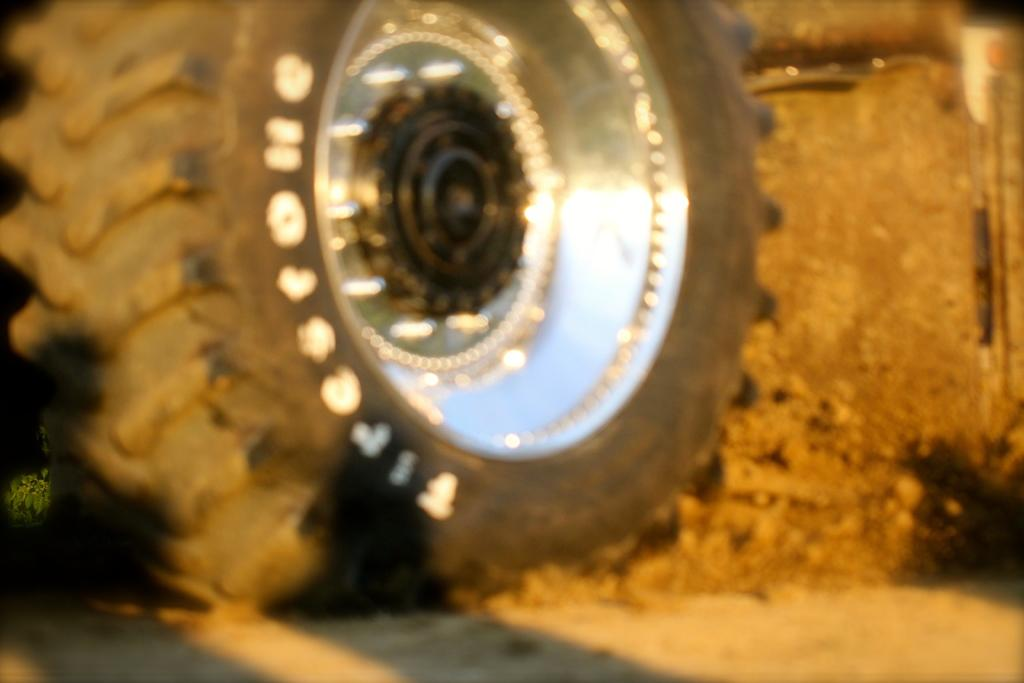What is the main subject of the image? The main subject of the image is a wheel of a vehicle. Where is the wheel located in the image? The wheel is on a surface in the image. Are there any additional details visible on the wheel? Yes, there is text on the wheel. Can you tell me how many jellyfish are swimming around the wheel in the image? There are no jellyfish present in the image; it features a wheel of a vehicle on a surface with text. 